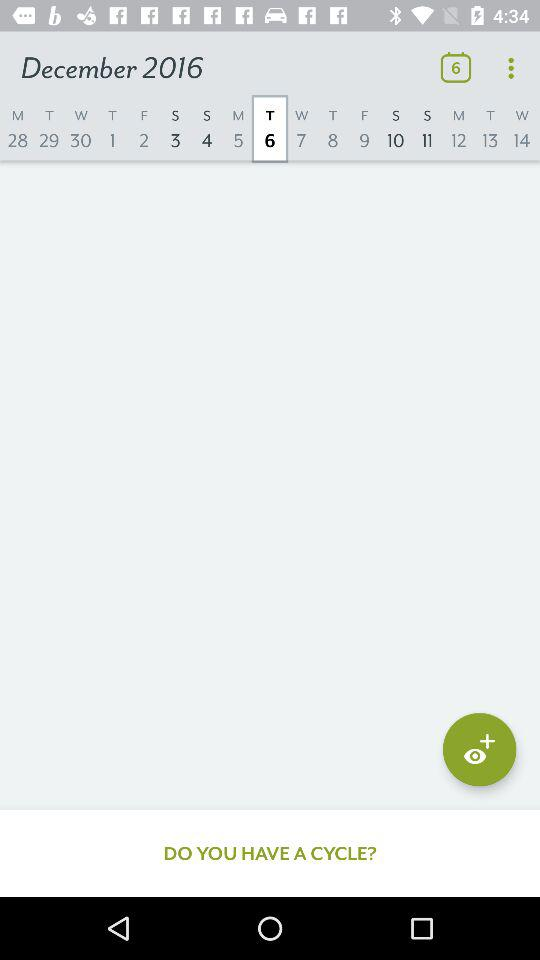What is the selected date? The selected date is Tuesday, December 6, 2016. 